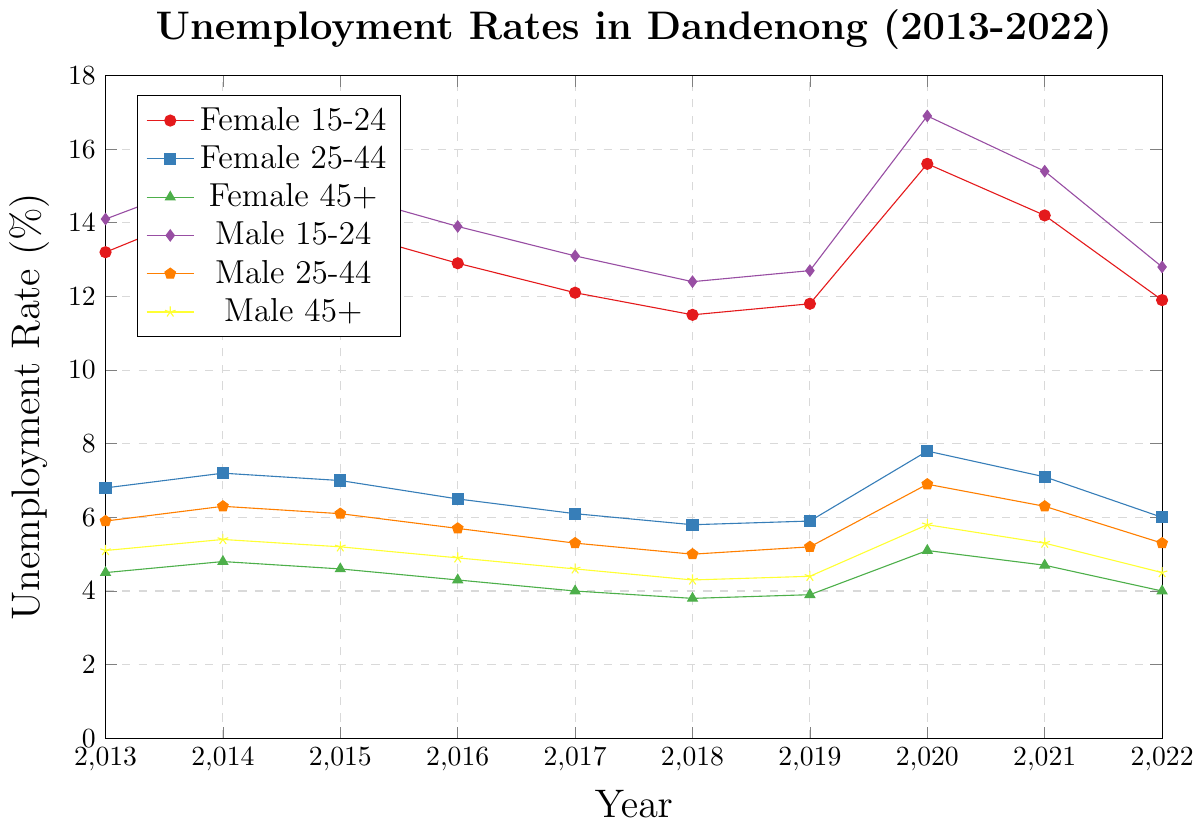Which age group had the highest unemployment rate in 2020? Observe the peaks of the lines in the year 2020. The group with the highest peak is the one with the highest unemployment rate. The age group "Male 15-24" has the highest peak at 16.9%.
Answer: Male 15-24 How did the unemployment rates for "Female 25-44" change from 2013 to 2022? Track the line for "Female 25-44" from 2013 to 2022. It starts at 6.8% in 2013 and ends at 6.0% in 2022. The rate generally declined over the years, except for notable increases in 2014 and 2020.
Answer: Declined Which gender and age group saw the largest increase in unemployment from 2019 to 2020? Compare the differences in heights of the lines for each age group and gender between 2019 and 2020. "Male 15-24" saw an increase from 12.7% to 16.9%, which is the largest increase of 4.2%.
Answer: Male 15-24 What is the average unemployment rate for "Female 45+" from 2013 to 2022? Calculate the average by summing the unemployment rates for "Female 45+" from 2013 to 2022 and then dividing by the number of years. The sum is 4.5 + 4.8 + 4.6 + 4.3 + 4.0 + 3.8 + 3.9 + 5.1 + 4.7 + 4.0 = 43.7. The average is 43.7 / 10 = 4.37%.
Answer: 4.37% Between 2013 and 2022, which age group consistently had the lowest unemployment rate for females? By following the lines for all female age groups over the years, identify which line (color) is consistently the lowest. "Female 45+" consistently has the lowest unemployment rates among females.
Answer: Female 45+ How did the unemployment rate for "Male 25-44" change between 2016 and 2018? Track the line for "Male 25-44" from 2016 to 2018. The rate decreases from 5.7% in 2016 to 5.0% in 2018.
Answer: Decreased Compare the unemployment rates of "Male 45+" and "Female 45+" in 2021. Which was higher? Look at the values for both "Male 45+" and "Female 45+" in the year 2021. "Male 45+" has a rate of 5.3%, while "Female 45+" has a rate of 4.7%. "Male 45+" is higher.
Answer: Male 45+ What were the unemployment trends for "Female 15-24" from 2017 to 2020? Follow the line for "Female 15-24" from 2017 to 2020. The rate decreases from 12.1% in 2017 to 11.5% in 2018, then slightly increases to 11.8% in 2019, and spikes to 15.6% in 2020.
Answer: Decrease, slight increase, then spike What is the difference in the unemployment rate between "Male 15-24" and "Female 15-24" in 2014? Subtract the unemployment rate of "Female 15-24" from "Male 15-24" in 2014. For "Male 15-24" it is 15.3% and for "Female 15-24" it is 14.5%. The difference is 15.3 - 14.5 = 0.8%.
Answer: 0.8% Which age group had the lowest unemployment rate in 2022? Identify the smallest value among all age groups and genders in the year 2022. "Female 45+" has the lowest rate at 4.0%.
Answer: Female 45+ 